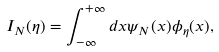<formula> <loc_0><loc_0><loc_500><loc_500>I _ { N } ( \eta ) = \int _ { - \infty } ^ { + \infty } d x \psi _ { N } ( x ) \phi _ { \eta } ( x ) ,</formula> 